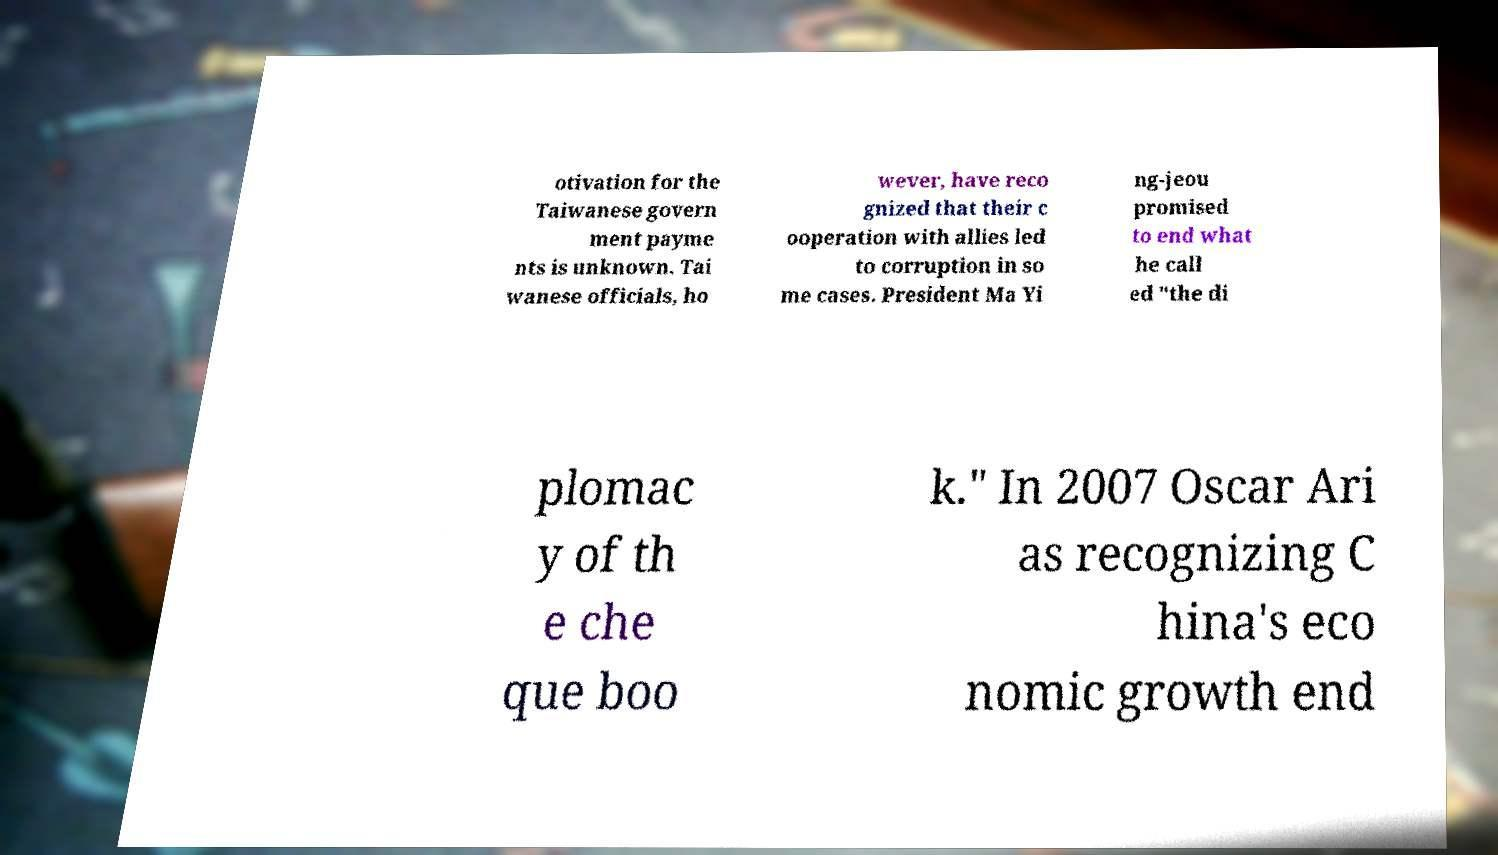What messages or text are displayed in this image? I need them in a readable, typed format. otivation for the Taiwanese govern ment payme nts is unknown. Tai wanese officials, ho wever, have reco gnized that their c ooperation with allies led to corruption in so me cases. President Ma Yi ng-jeou promised to end what he call ed "the di plomac y of th e che que boo k." In 2007 Oscar Ari as recognizing C hina's eco nomic growth end 